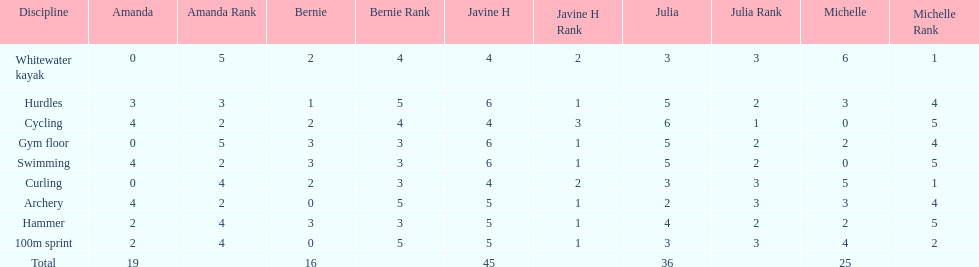What is the last discipline listed on this chart? 100m sprint. 